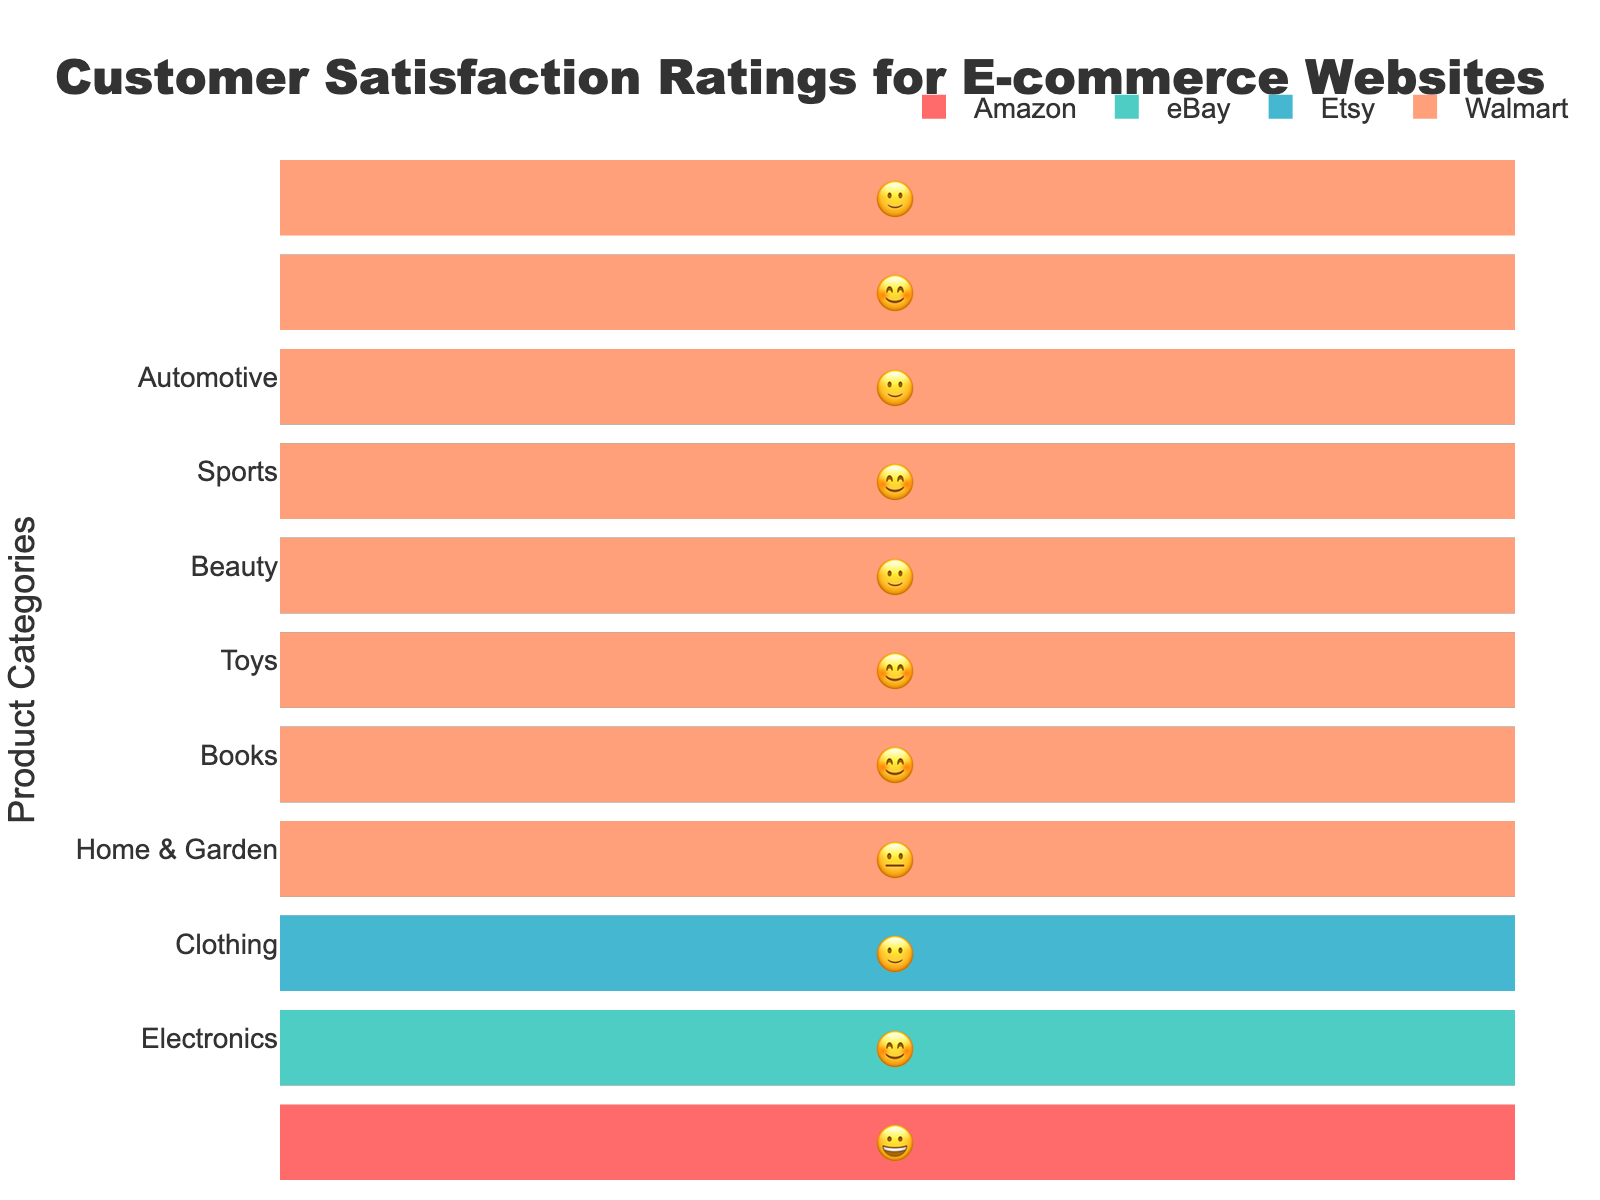What is the overall title of the figure? The title is located at the top of the figure and serves as a summary of the content that the chart represents.
Answer: Customer Satisfaction Ratings for E-commerce Websites Which e-commerce website received the highest satisfaction rating for Electronics? Look at the emojis for the Electronics category; the website with the most positive emoji (😀) is the one with the highest rating.
Answer: Amazon How does Walmart's customer satisfaction compare in Clothing vs. Electronics? Compare the emojis for Walmart in both categories. In Clothing, Walmart has 😊, and in Electronics, it has 😐. Since 😊 is more positive than 😐, Walmart performs better in Clothing.
Answer: Clothing is better What are the customer satisfaction ratings for eBay in the Home & Garden category? Refer to the ratings for eBay in the Home & Garden category. Find the corresponding emoji.
Answer: 🙂 Which product category has the most consistent satisfaction ratings across all e-commerce websites? Look for the category where the emojis are the most similar across Amazon, eBay, Etsy, and Walmart.
Answer: Home & Garden What is the average satisfaction rating for Amazon across all product categories? Convert the emojis to a numerical scale (😀=4, 😊=3, 🙂=2, 😐=1), sum the ratings for Amazon, and then divide by the number of categories. The ratings are (4+3+4+4+3+3+4+3)=28 across 8 categories. 28 / 8 = 3.5, which corresponds to 😊 on our scale.
Answer: 😊 Which e-commerce website shows the largest range of satisfaction ratings across different categories? Evaluate the span from the most positive to the least positive emoji for each e-commerce website. Etsy varies from 😀 to 😐; Amazon and Walmart do not exhibit such range.
Answer: Etsy Are there any categories where all websites received a negative or neutral rating? Verify if there is any category where all the emojis are 🙂, 😐 or worse. All websites have at least one positive emoji (😊 or 😀) in each category.
Answer: No How do the satisfaction ratings for Amazon and eBay compare in the Sports category? Reflect on the ratings for the Sports category; Amazon has 😀, and eBay has 🙂. Since 😀 is more positive than 🙂, Amazon scores higher.
Answer: Amazon is higher Which e-commerce website has the best overall satisfaction rating in the Automotive category? Look at the emojis for the Automotive category related to all websites. The website with the most positive emoji (😀) is eBay.
Answer: eBay 